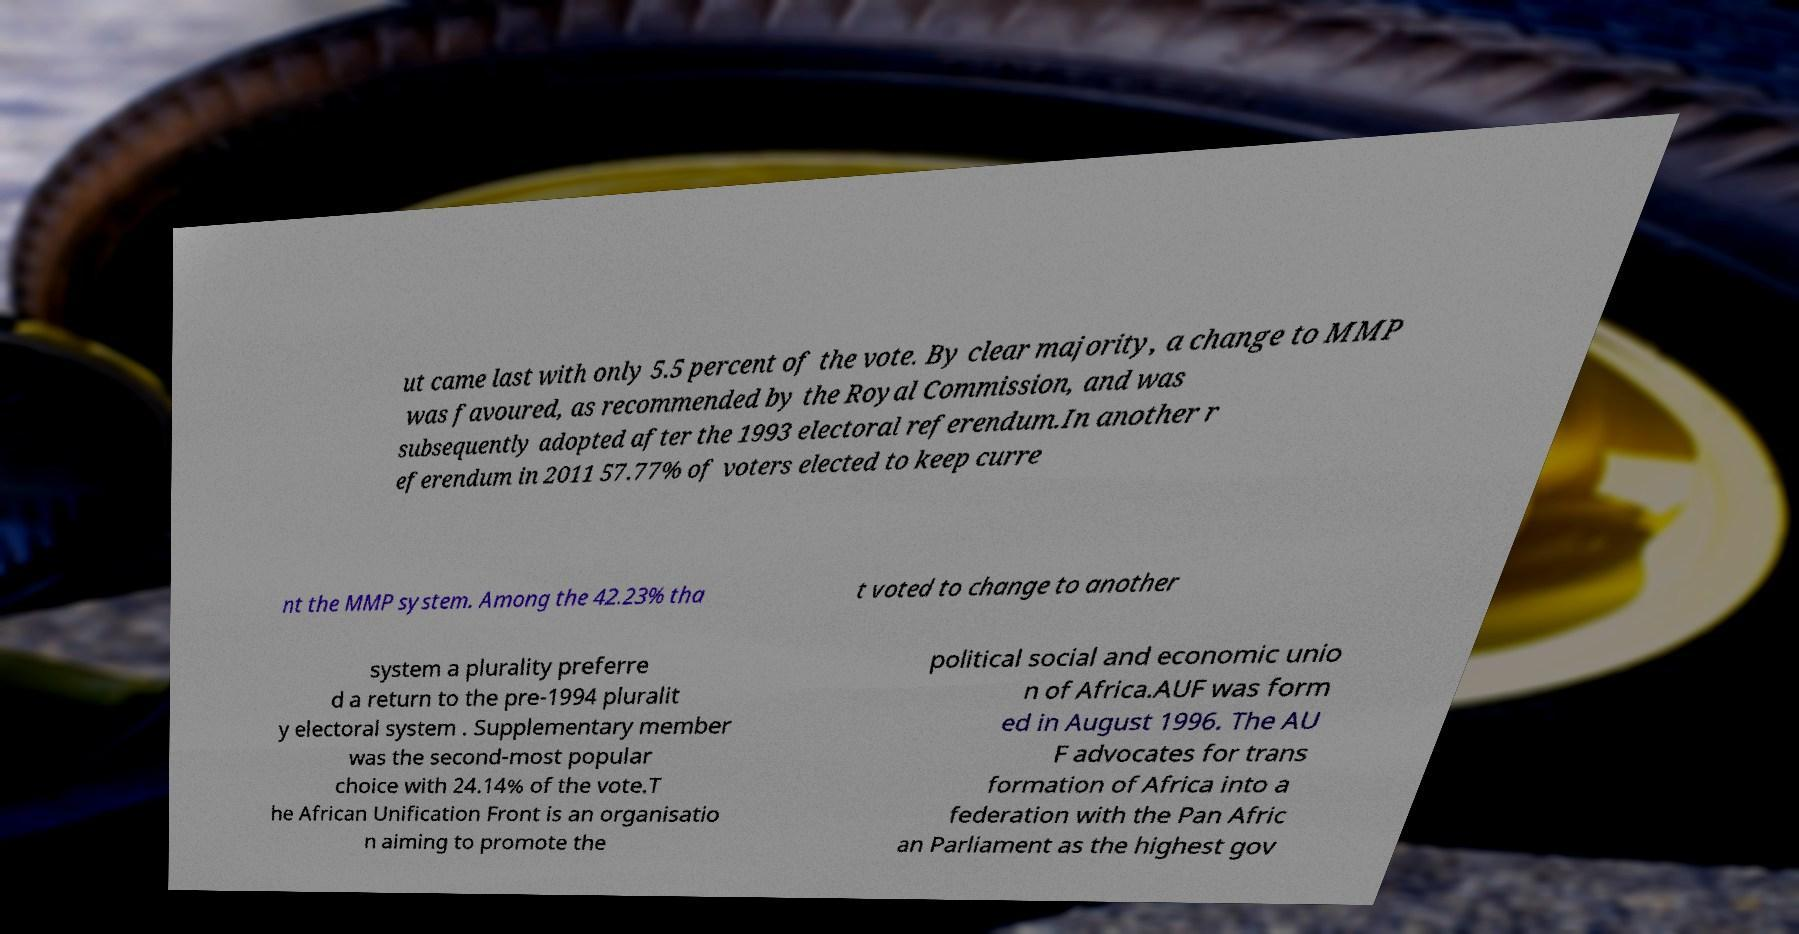Please read and relay the text visible in this image. What does it say? ut came last with only 5.5 percent of the vote. By clear majority, a change to MMP was favoured, as recommended by the Royal Commission, and was subsequently adopted after the 1993 electoral referendum.In another r eferendum in 2011 57.77% of voters elected to keep curre nt the MMP system. Among the 42.23% tha t voted to change to another system a plurality preferre d a return to the pre-1994 pluralit y electoral system . Supplementary member was the second-most popular choice with 24.14% of the vote.T he African Unification Front is an organisatio n aiming to promote the political social and economic unio n of Africa.AUF was form ed in August 1996. The AU F advocates for trans formation of Africa into a federation with the Pan Afric an Parliament as the highest gov 